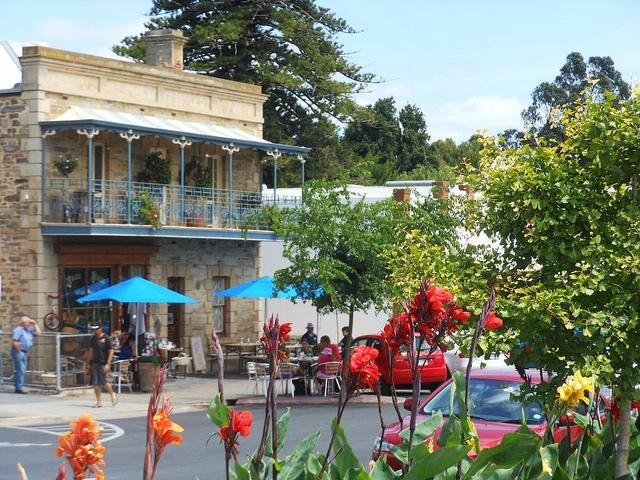Where does this scene take place?

Choices:
A) cafe
B) house
C) condo
D) club cafe 